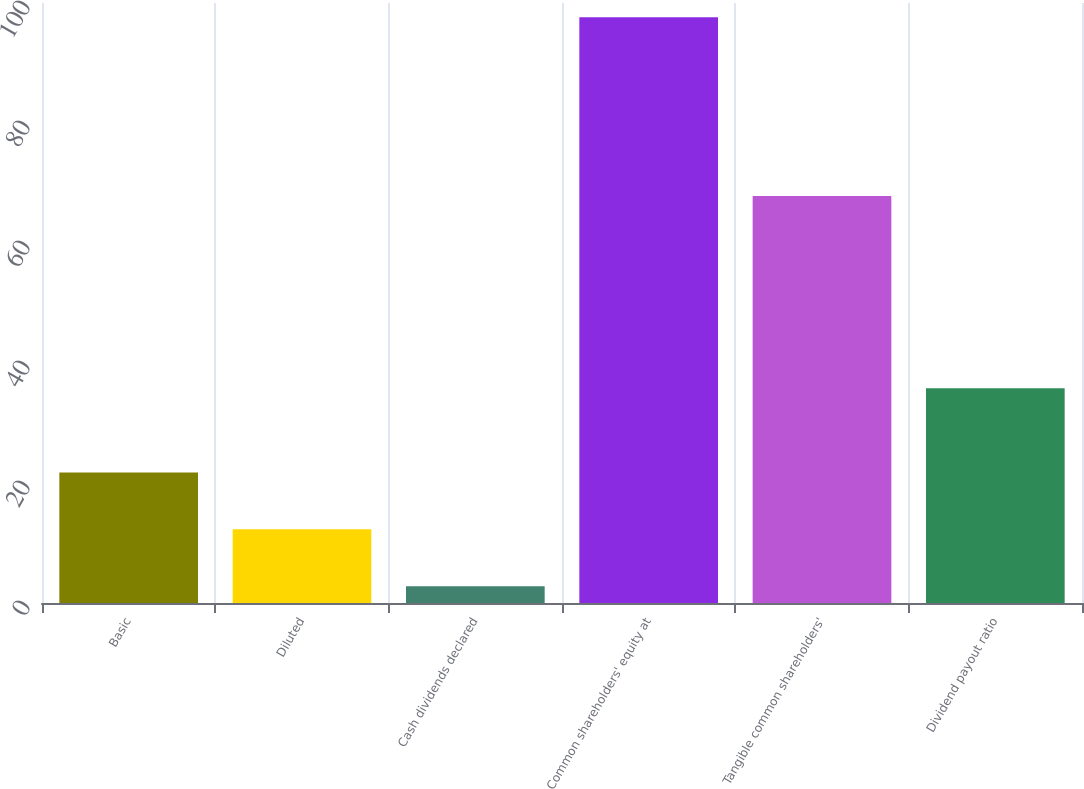<chart> <loc_0><loc_0><loc_500><loc_500><bar_chart><fcel>Basic<fcel>Diluted<fcel>Cash dividends declared<fcel>Common shareholders' equity at<fcel>Tangible common shareholders'<fcel>Dividend payout ratio<nl><fcel>21.76<fcel>12.28<fcel>2.8<fcel>97.64<fcel>67.85<fcel>35.81<nl></chart> 